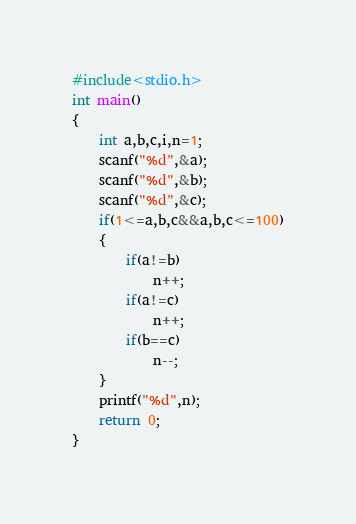Convert code to text. <code><loc_0><loc_0><loc_500><loc_500><_C_>#include<stdio.h>
int main()
{
    int a,b,c,i,n=1;
    scanf("%d",&a);
    scanf("%d",&b);
    scanf("%d",&c);
    if(1<=a,b,c&&a,b,c<=100)
    {
        if(a!=b)
            n++;
        if(a!=c)
            n++;
        if(b==c)
            n--;
    }
    printf("%d",n);
    return 0;
}

</code> 